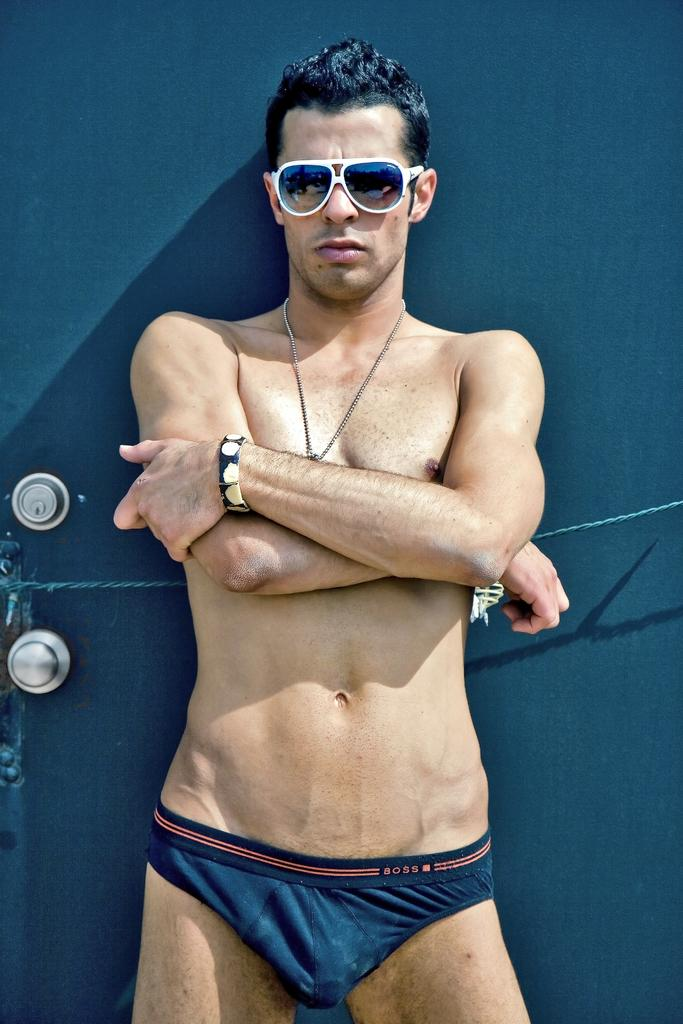What is the main subject of the image? There is a man standing in the center of the image. What can be observed about the man's appearance? The man is wearing glasses. What can be seen in the background of the image? There is a door visible in the background of the image. What type of wood is the man using to brush his teeth in the image? There is no wood or toothbrushing activity present in the image. 